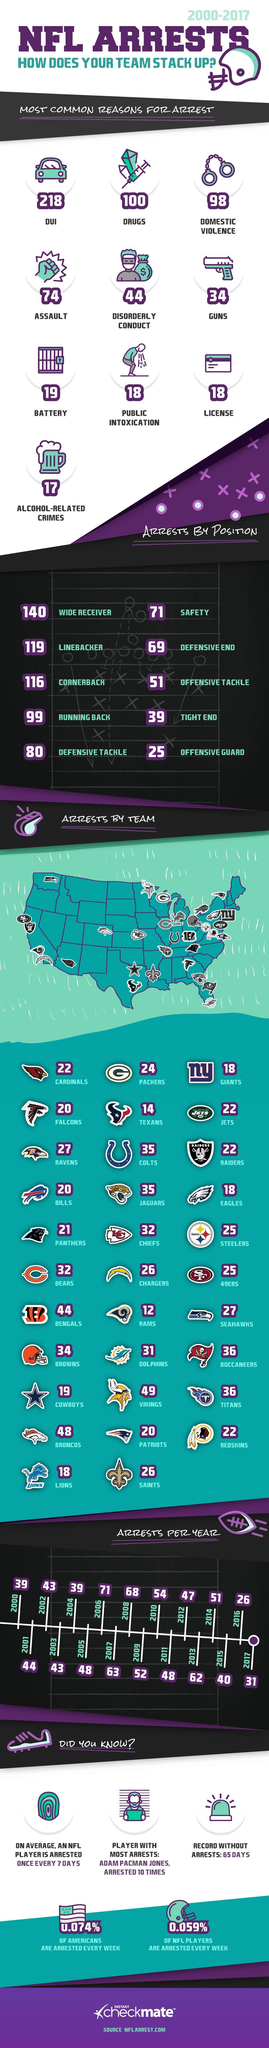How many teams are in NFL?
Answer the question with a short phrase. 32 What is the number of NFL arrests reported due to alcohol-related crimes during 2000-2017? 17 How many arrests were reported in 'Dallas Cowboys' NFL team during 2000-2017? 19 Which NFL position has seen the least number of arrests during 2000-2017? OFFENSIVE GUARD Which NFL position has seen the most number of arrests during 2000-2017? WIDE RECEIVER What NFL team has the most arrests since 2000? BENGALS What is the reason for the most arrests of NFL players since 2000? DUI How many NFL players were arrested due to drug usage during 2000-2017? 100 How many arrests were recorded in 'New York Giants' NFL team during 2000-2017? 18 